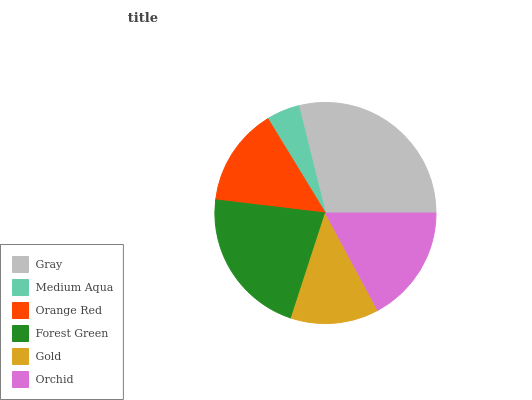Is Medium Aqua the minimum?
Answer yes or no. Yes. Is Gray the maximum?
Answer yes or no. Yes. Is Orange Red the minimum?
Answer yes or no. No. Is Orange Red the maximum?
Answer yes or no. No. Is Orange Red greater than Medium Aqua?
Answer yes or no. Yes. Is Medium Aqua less than Orange Red?
Answer yes or no. Yes. Is Medium Aqua greater than Orange Red?
Answer yes or no. No. Is Orange Red less than Medium Aqua?
Answer yes or no. No. Is Orchid the high median?
Answer yes or no. Yes. Is Orange Red the low median?
Answer yes or no. Yes. Is Gold the high median?
Answer yes or no. No. Is Orchid the low median?
Answer yes or no. No. 